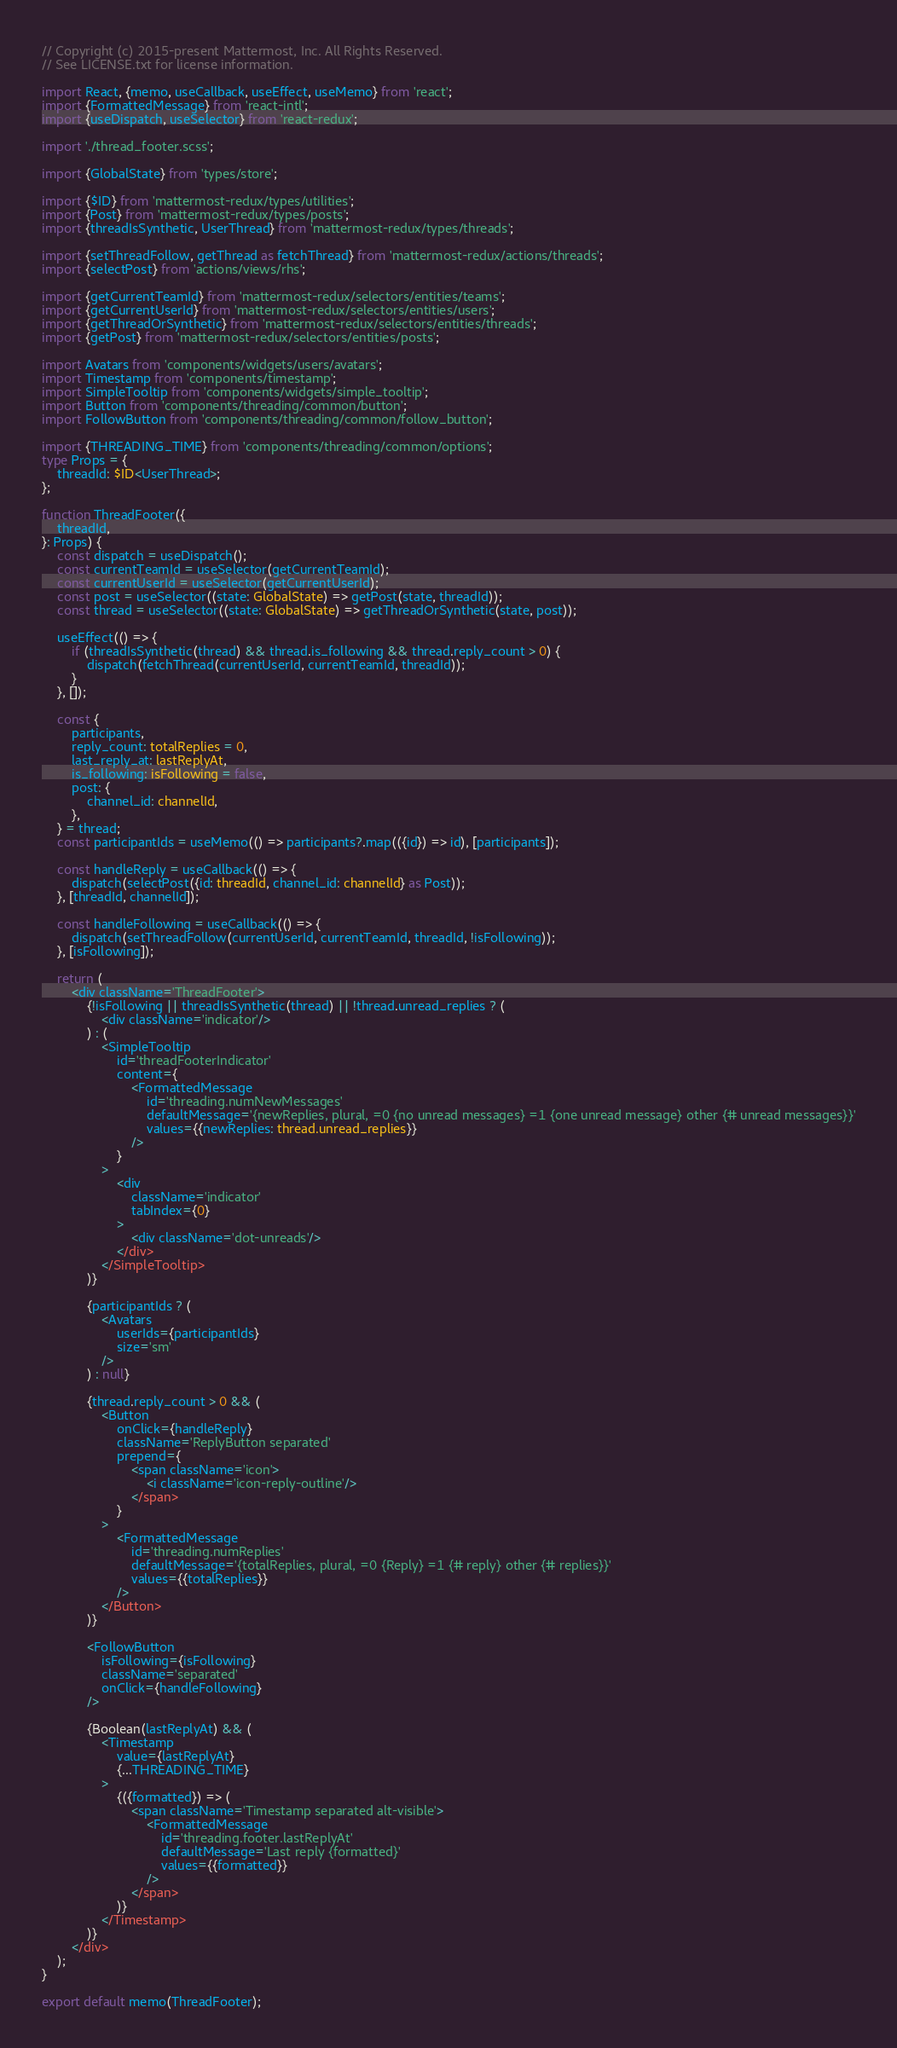<code> <loc_0><loc_0><loc_500><loc_500><_TypeScript_>// Copyright (c) 2015-present Mattermost, Inc. All Rights Reserved.
// See LICENSE.txt for license information.

import React, {memo, useCallback, useEffect, useMemo} from 'react';
import {FormattedMessage} from 'react-intl';
import {useDispatch, useSelector} from 'react-redux';

import './thread_footer.scss';

import {GlobalState} from 'types/store';

import {$ID} from 'mattermost-redux/types/utilities';
import {Post} from 'mattermost-redux/types/posts';
import {threadIsSynthetic, UserThread} from 'mattermost-redux/types/threads';

import {setThreadFollow, getThread as fetchThread} from 'mattermost-redux/actions/threads';
import {selectPost} from 'actions/views/rhs';

import {getCurrentTeamId} from 'mattermost-redux/selectors/entities/teams';
import {getCurrentUserId} from 'mattermost-redux/selectors/entities/users';
import {getThreadOrSynthetic} from 'mattermost-redux/selectors/entities/threads';
import {getPost} from 'mattermost-redux/selectors/entities/posts';

import Avatars from 'components/widgets/users/avatars';
import Timestamp from 'components/timestamp';
import SimpleTooltip from 'components/widgets/simple_tooltip';
import Button from 'components/threading/common/button';
import FollowButton from 'components/threading/common/follow_button';

import {THREADING_TIME} from 'components/threading/common/options';
type Props = {
    threadId: $ID<UserThread>;
};

function ThreadFooter({
    threadId,
}: Props) {
    const dispatch = useDispatch();
    const currentTeamId = useSelector(getCurrentTeamId);
    const currentUserId = useSelector(getCurrentUserId);
    const post = useSelector((state: GlobalState) => getPost(state, threadId));
    const thread = useSelector((state: GlobalState) => getThreadOrSynthetic(state, post));

    useEffect(() => {
        if (threadIsSynthetic(thread) && thread.is_following && thread.reply_count > 0) {
            dispatch(fetchThread(currentUserId, currentTeamId, threadId));
        }
    }, []);

    const {
        participants,
        reply_count: totalReplies = 0,
        last_reply_at: lastReplyAt,
        is_following: isFollowing = false,
        post: {
            channel_id: channelId,
        },
    } = thread;
    const participantIds = useMemo(() => participants?.map(({id}) => id), [participants]);

    const handleReply = useCallback(() => {
        dispatch(selectPost({id: threadId, channel_id: channelId} as Post));
    }, [threadId, channelId]);

    const handleFollowing = useCallback(() => {
        dispatch(setThreadFollow(currentUserId, currentTeamId, threadId, !isFollowing));
    }, [isFollowing]);

    return (
        <div className='ThreadFooter'>
            {!isFollowing || threadIsSynthetic(thread) || !thread.unread_replies ? (
                <div className='indicator'/>
            ) : (
                <SimpleTooltip
                    id='threadFooterIndicator'
                    content={
                        <FormattedMessage
                            id='threading.numNewMessages'
                            defaultMessage='{newReplies, plural, =0 {no unread messages} =1 {one unread message} other {# unread messages}}'
                            values={{newReplies: thread.unread_replies}}
                        />
                    }
                >
                    <div
                        className='indicator'
                        tabIndex={0}
                    >
                        <div className='dot-unreads'/>
                    </div>
                </SimpleTooltip>
            )}

            {participantIds ? (
                <Avatars
                    userIds={participantIds}
                    size='sm'
                />
            ) : null}

            {thread.reply_count > 0 && (
                <Button
                    onClick={handleReply}
                    className='ReplyButton separated'
                    prepend={
                        <span className='icon'>
                            <i className='icon-reply-outline'/>
                        </span>
                    }
                >
                    <FormattedMessage
                        id='threading.numReplies'
                        defaultMessage='{totalReplies, plural, =0 {Reply} =1 {# reply} other {# replies}}'
                        values={{totalReplies}}
                    />
                </Button>
            )}

            <FollowButton
                isFollowing={isFollowing}
                className='separated'
                onClick={handleFollowing}
            />

            {Boolean(lastReplyAt) && (
                <Timestamp
                    value={lastReplyAt}
                    {...THREADING_TIME}
                >
                    {({formatted}) => (
                        <span className='Timestamp separated alt-visible'>
                            <FormattedMessage
                                id='threading.footer.lastReplyAt'
                                defaultMessage='Last reply {formatted}'
                                values={{formatted}}
                            />
                        </span>
                    )}
                </Timestamp>
            )}
        </div>
    );
}

export default memo(ThreadFooter);
</code> 